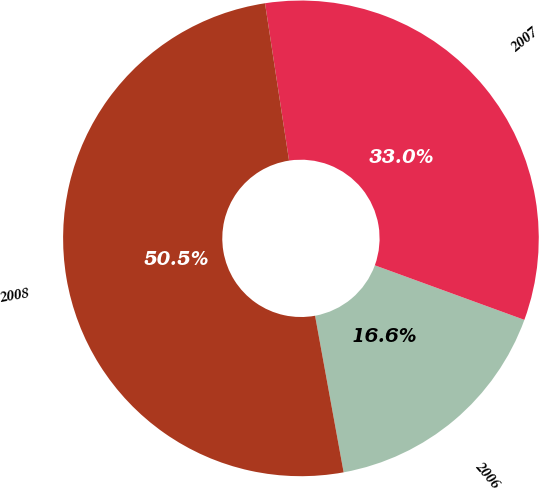<chart> <loc_0><loc_0><loc_500><loc_500><pie_chart><fcel>2006<fcel>2007<fcel>2008<nl><fcel>16.56%<fcel>32.98%<fcel>50.46%<nl></chart> 